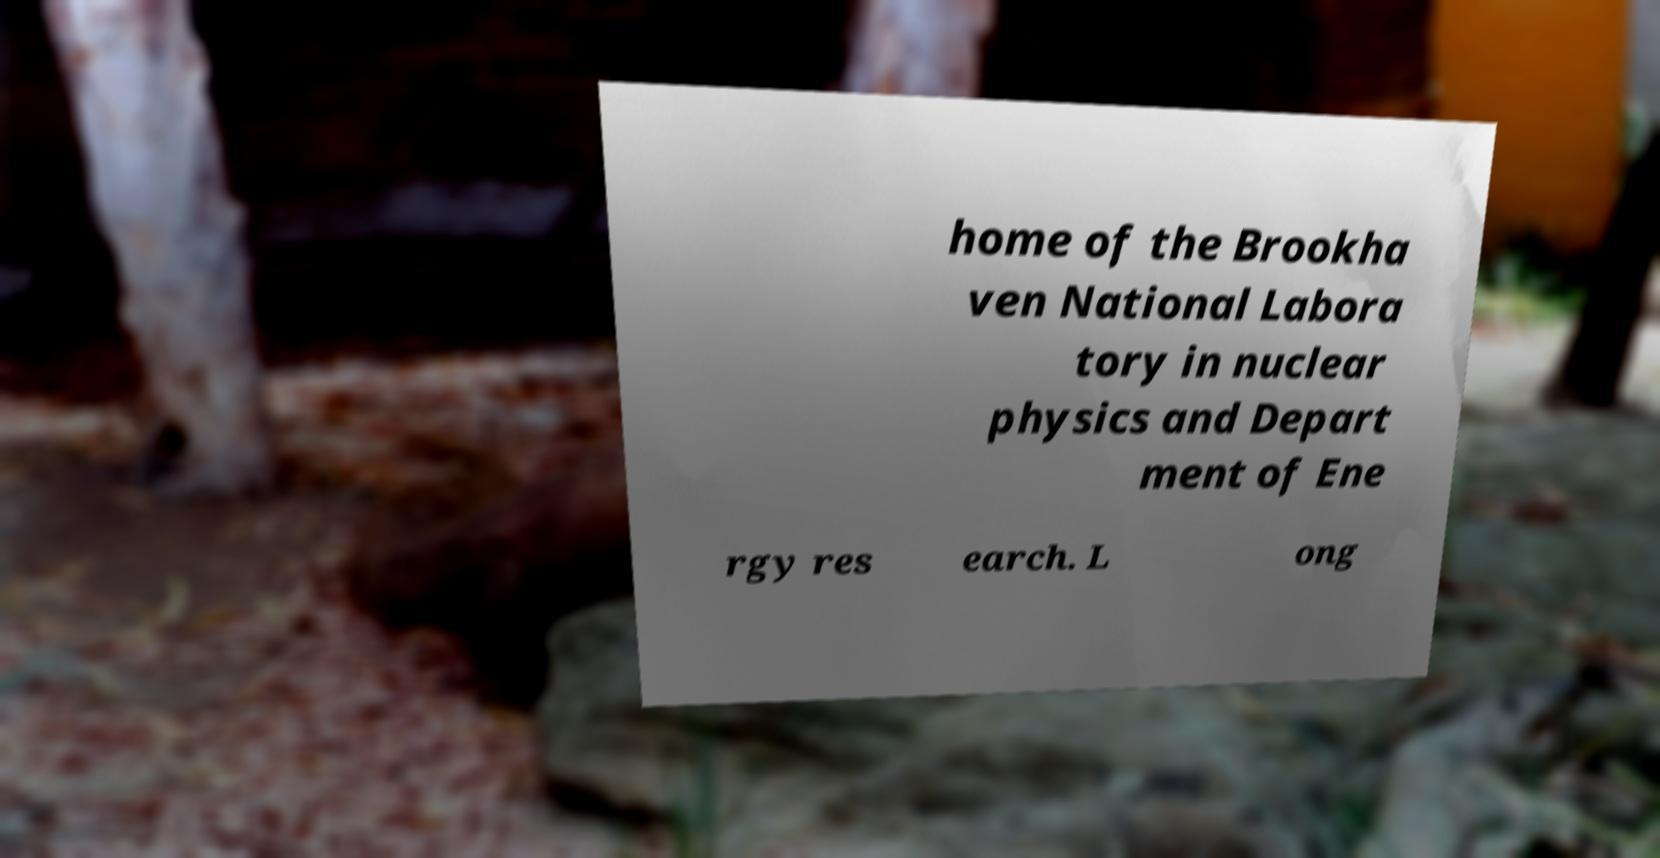I need the written content from this picture converted into text. Can you do that? home of the Brookha ven National Labora tory in nuclear physics and Depart ment of Ene rgy res earch. L ong 